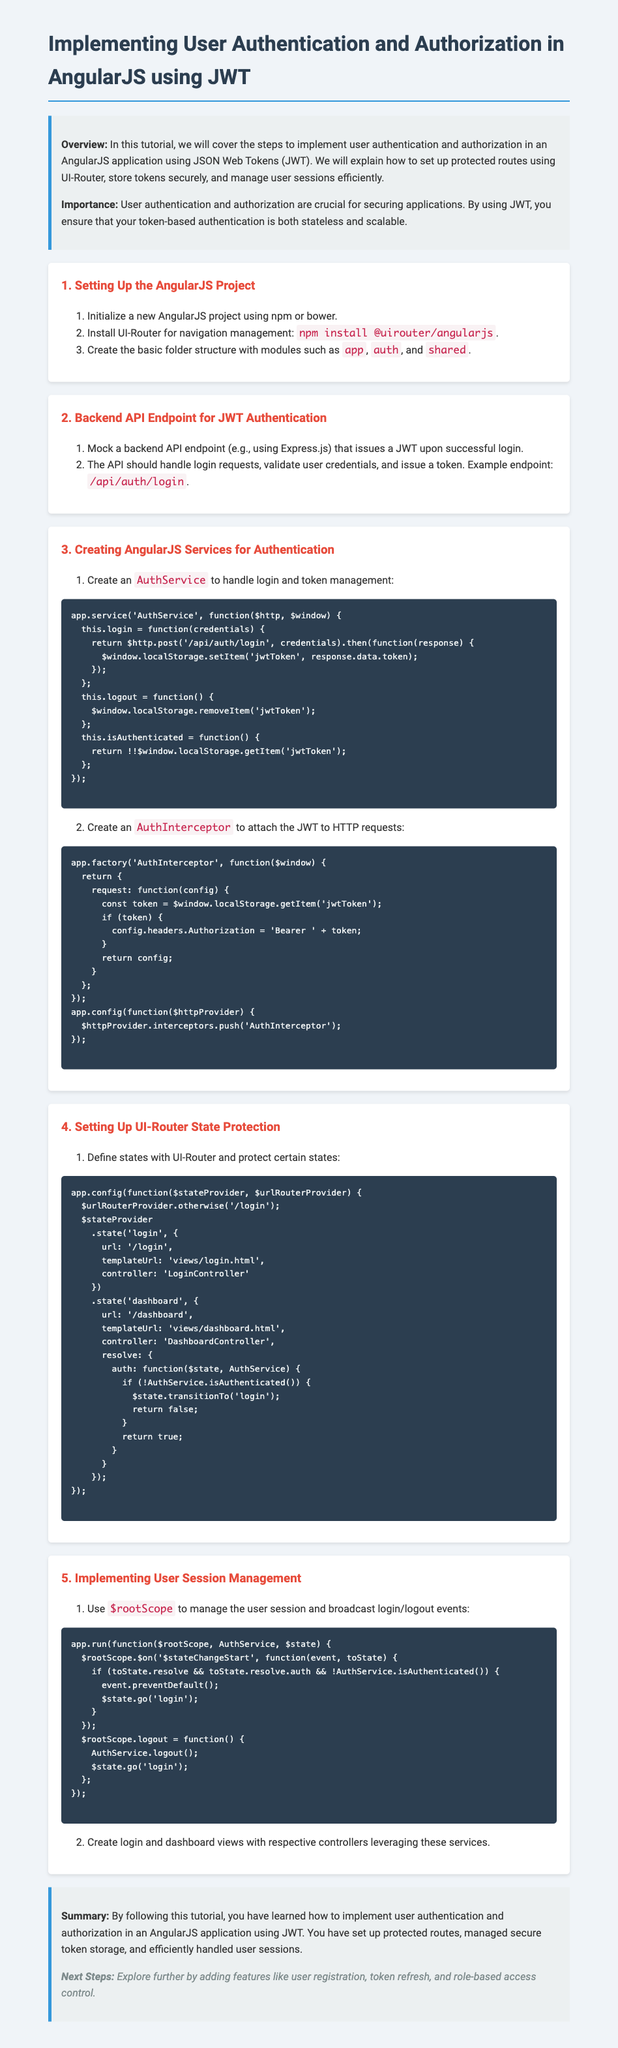What is the title of the document? The title is stated in the document's heading.
Answer: AngularJS JWT Authentication Homework What is the first step in setting up the AngularJS project? The first step is detailed in the list of steps in the 'Setting Up the AngularJS Project' section.
Answer: Initialize a new AngularJS project using npm or bower What is the API endpoint for JWT authentication mentioned in the document? The API endpoint is specified in the step regarding backend setup for JWT authentication.
Answer: /api/auth/login What service is created to handle login and token management? The service is identified in the section that describes creating AngularJS services for authentication.
Answer: AuthService Which AngularJS module is used for navigation management? The specific module is mentioned in the initial setup step of the project.
Answer: UI-Router What variable is used to manage user sessions in the document? This variable is part of the session management section within the document.
Answer: $rootScope What is the next step mentioned after completing the tutorial? The next steps are outlined at the conclusion of the document.
Answer: Explore further by adding features like user registration, token refresh, and role-based access control What color is used for the headers in the document's style? The document specifies the color used for the headers in the CSS section.
Answer: #2c3e50 